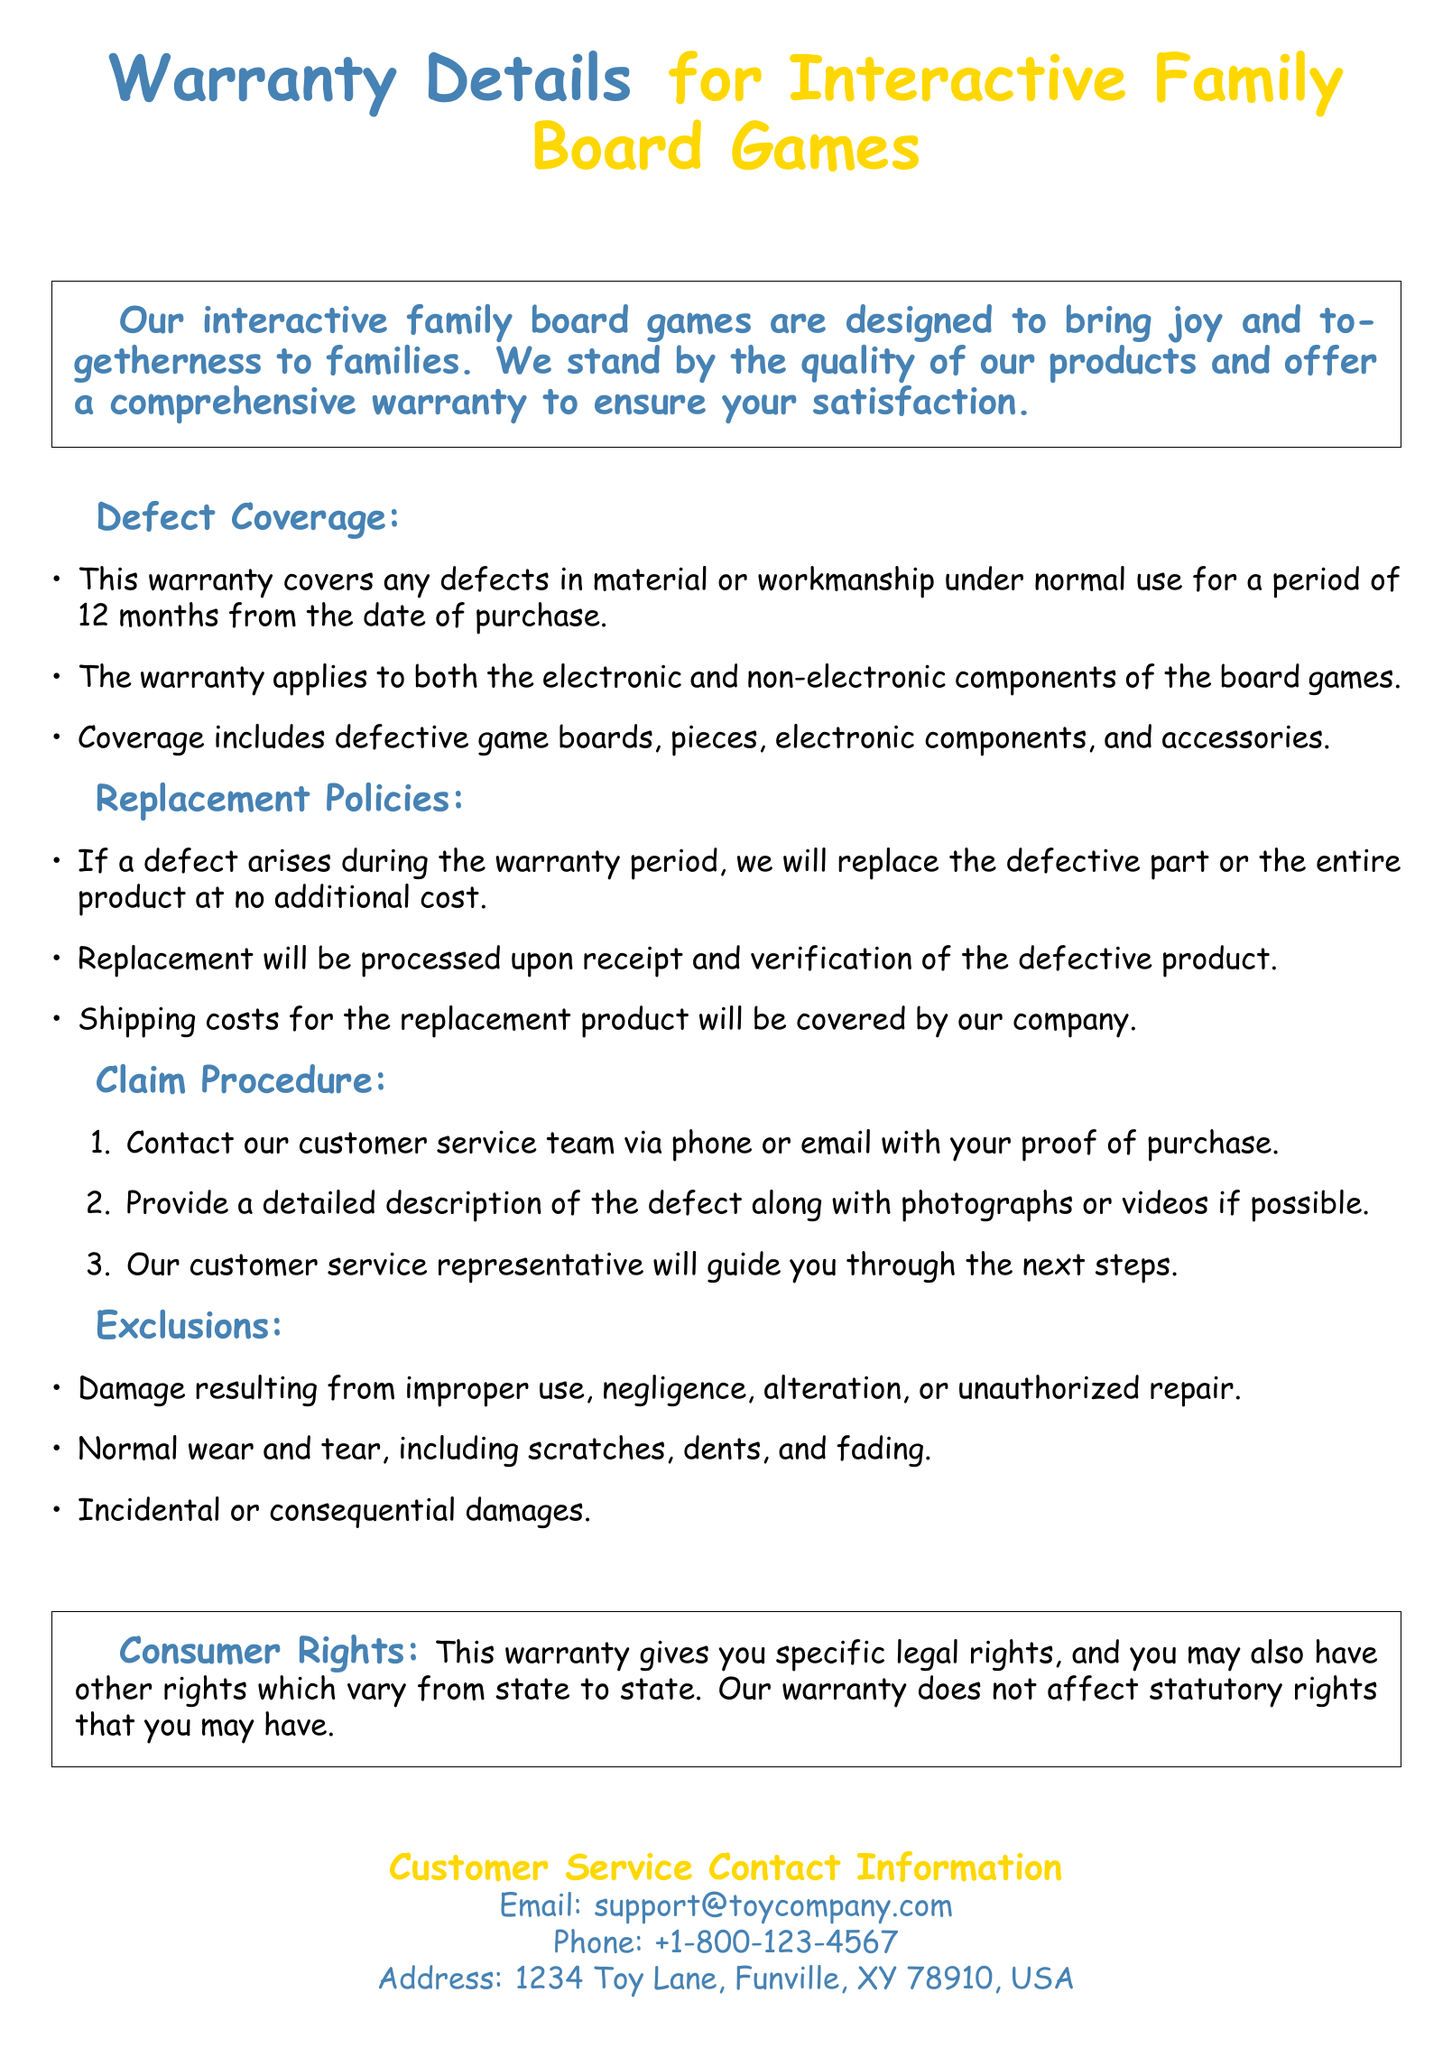What is the warranty period? The warranty period for the interactive family board games is 12 months from the date of purchase.
Answer: 12 months What does the warranty cover? The warranty covers defects in material or workmanship under normal use, including defective game boards, pieces, electronic components, and accessories.
Answer: Defects in material or workmanship What should you provide when contacting customer service? You should provide your proof of purchase when contacting customer service.
Answer: Proof of purchase What is excluded from the warranty? Damage resulting from improper use, negligence, alteration, or unauthorized repair is excluded from the warranty.
Answer: Improper use What will happen if a defect arises during the warranty period? If a defect arises during the warranty period, the company will replace the defective part or the entire product at no additional cost.
Answer: Replace at no additional cost What contact methods are provided for customer service? The document provides email and phone as methods for contacting customer service.
Answer: Email and phone How will shipping costs for replacements be handled? Shipping costs for the replacement product will be covered by the company.
Answer: Covered by our company Where is the company located? The company is located at 1234 Toy Lane, Funville, XY 78910, USA.
Answer: 1234 Toy Lane, Funville, XY 78910, USA 